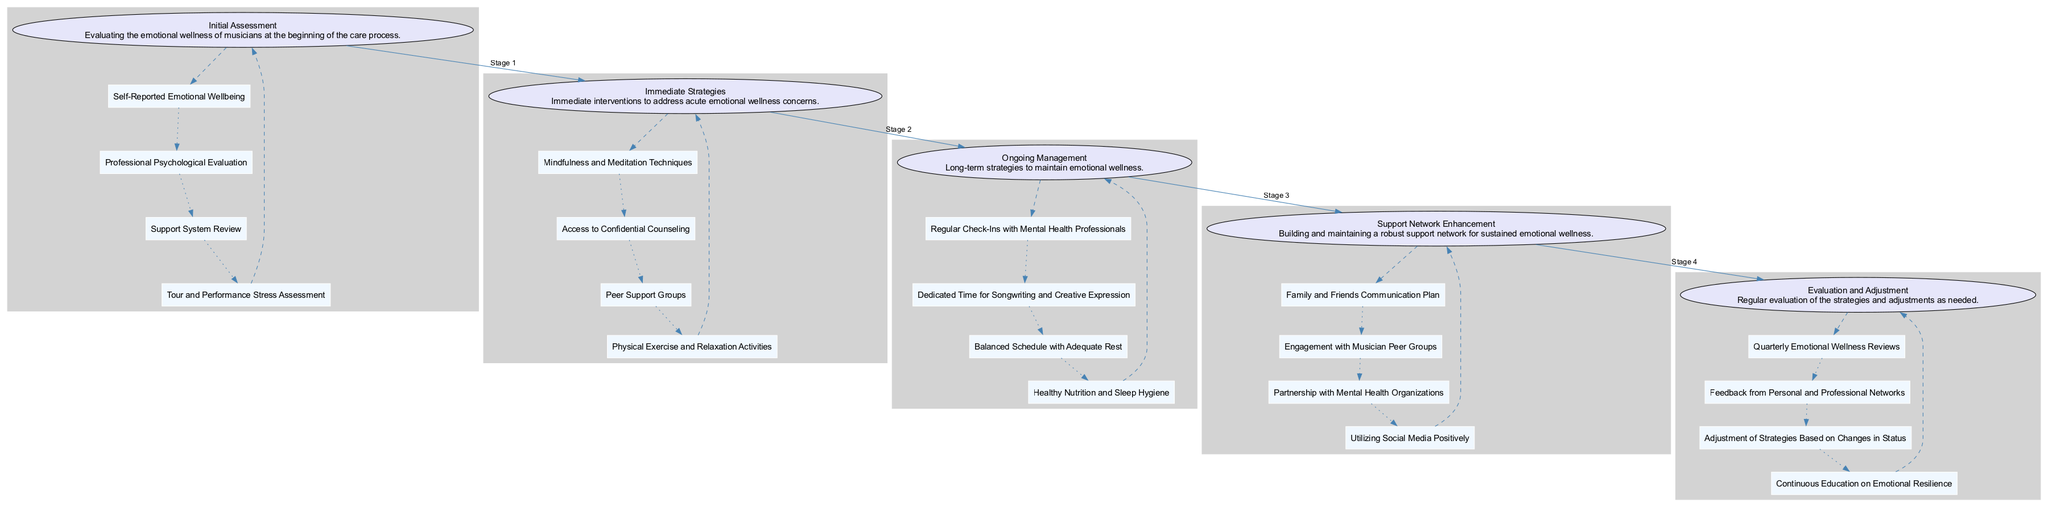What is the first stage in the clinical pathway? The diagram indicates that the first stage of the clinical pathway is labeled "Initial Assessment". This is the first node presented.
Answer: Initial Assessment How many elements are included in the "Ongoing Management" stage? By examining the "Ongoing Management" stage node, we can count four distinct elements listed under it. Thus, the total is four elements.
Answer: Four What is one immediate strategy for emotional wellness? Looking at the "Immediate Strategies" stage, one of the listed elements is "Mindfulness and Meditation Techniques". This directly answers the question.
Answer: Mindfulness and Meditation Techniques Which stage follows "Support Network Enhancement"? The diagram connects "Support Network Enhancement" to the next stage, which is "Evaluation and Adjustment". This is the sequential flow of stages.
Answer: Evaluation and Adjustment How many total stages are there in the clinical pathway? Counting each stage shown in the diagram from top to bottom, there are five stages shown in total.
Answer: Five What is the purpose of the "Evaluation and Adjustment" stage? The description under the "Evaluation and Adjustment" stage indicates it serves to regularly evaluate strategies and adjust them as necessary to maintain emotional wellness effectively.
Answer: Regular evaluation of the strategies What type of reviews are conducted in the "Evaluation and Adjustment" stage? The diagram highlights "Quarterly Emotional Wellness Reviews" as one of the elements in this stage, indicating the frequency of reviews.
Answer: Quarterly What stage comes before "Immediate Strategies"? The diagram shows "Initial Assessment" as the preceding stage, making it the step taken before the "Immediate Strategies".
Answer: Initial Assessment What is a key element in the "Support Network Enhancement" stage? The “Support Network Enhancement” stage lists “Engagement with Musician Peer Groups” as one of the key elements, demonstrating a core strategy for emotional wellness.
Answer: Engagement with Musician Peer Groups 